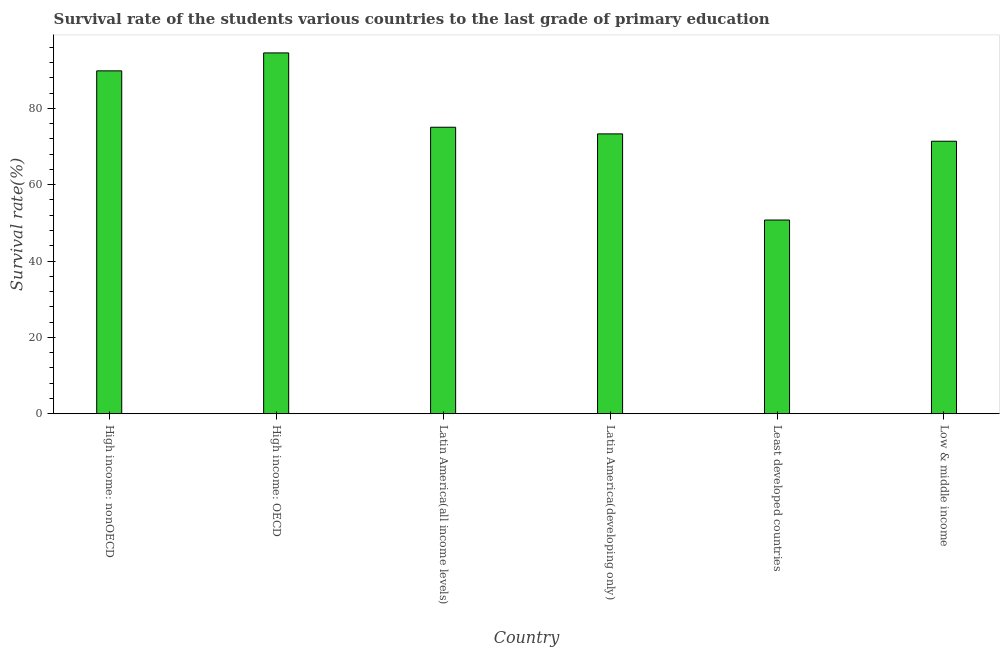Does the graph contain any zero values?
Offer a very short reply. No. What is the title of the graph?
Provide a succinct answer. Survival rate of the students various countries to the last grade of primary education. What is the label or title of the Y-axis?
Provide a short and direct response. Survival rate(%). What is the survival rate in primary education in Latin America(developing only)?
Offer a terse response. 73.32. Across all countries, what is the maximum survival rate in primary education?
Make the answer very short. 94.53. Across all countries, what is the minimum survival rate in primary education?
Your answer should be very brief. 50.75. In which country was the survival rate in primary education maximum?
Make the answer very short. High income: OECD. In which country was the survival rate in primary education minimum?
Offer a terse response. Least developed countries. What is the sum of the survival rate in primary education?
Ensure brevity in your answer.  454.88. What is the difference between the survival rate in primary education in High income: nonOECD and Latin America(all income levels)?
Your answer should be compact. 14.77. What is the average survival rate in primary education per country?
Keep it short and to the point. 75.81. What is the median survival rate in primary education?
Offer a very short reply. 74.19. What is the ratio of the survival rate in primary education in Latin America(all income levels) to that in Low & middle income?
Your answer should be compact. 1.05. What is the difference between the highest and the second highest survival rate in primary education?
Offer a terse response. 4.7. What is the difference between the highest and the lowest survival rate in primary education?
Your response must be concise. 43.78. In how many countries, is the survival rate in primary education greater than the average survival rate in primary education taken over all countries?
Your response must be concise. 2. How many countries are there in the graph?
Your answer should be compact. 6. What is the Survival rate(%) in High income: nonOECD?
Offer a very short reply. 89.83. What is the Survival rate(%) of High income: OECD?
Offer a terse response. 94.53. What is the Survival rate(%) of Latin America(all income levels)?
Your response must be concise. 75.06. What is the Survival rate(%) of Latin America(developing only)?
Give a very brief answer. 73.32. What is the Survival rate(%) in Least developed countries?
Offer a terse response. 50.75. What is the Survival rate(%) in Low & middle income?
Offer a very short reply. 71.39. What is the difference between the Survival rate(%) in High income: nonOECD and High income: OECD?
Offer a very short reply. -4.7. What is the difference between the Survival rate(%) in High income: nonOECD and Latin America(all income levels)?
Your answer should be compact. 14.77. What is the difference between the Survival rate(%) in High income: nonOECD and Latin America(developing only)?
Your answer should be compact. 16.51. What is the difference between the Survival rate(%) in High income: nonOECD and Least developed countries?
Your response must be concise. 39.08. What is the difference between the Survival rate(%) in High income: nonOECD and Low & middle income?
Offer a very short reply. 18.44. What is the difference between the Survival rate(%) in High income: OECD and Latin America(all income levels)?
Offer a very short reply. 19.47. What is the difference between the Survival rate(%) in High income: OECD and Latin America(developing only)?
Your response must be concise. 21.21. What is the difference between the Survival rate(%) in High income: OECD and Least developed countries?
Offer a terse response. 43.78. What is the difference between the Survival rate(%) in High income: OECD and Low & middle income?
Provide a succinct answer. 23.14. What is the difference between the Survival rate(%) in Latin America(all income levels) and Latin America(developing only)?
Ensure brevity in your answer.  1.74. What is the difference between the Survival rate(%) in Latin America(all income levels) and Least developed countries?
Offer a terse response. 24.31. What is the difference between the Survival rate(%) in Latin America(all income levels) and Low & middle income?
Your answer should be compact. 3.66. What is the difference between the Survival rate(%) in Latin America(developing only) and Least developed countries?
Give a very brief answer. 22.57. What is the difference between the Survival rate(%) in Latin America(developing only) and Low & middle income?
Provide a succinct answer. 1.93. What is the difference between the Survival rate(%) in Least developed countries and Low & middle income?
Ensure brevity in your answer.  -20.64. What is the ratio of the Survival rate(%) in High income: nonOECD to that in Latin America(all income levels)?
Your answer should be very brief. 1.2. What is the ratio of the Survival rate(%) in High income: nonOECD to that in Latin America(developing only)?
Make the answer very short. 1.23. What is the ratio of the Survival rate(%) in High income: nonOECD to that in Least developed countries?
Your answer should be very brief. 1.77. What is the ratio of the Survival rate(%) in High income: nonOECD to that in Low & middle income?
Provide a short and direct response. 1.26. What is the ratio of the Survival rate(%) in High income: OECD to that in Latin America(all income levels)?
Your answer should be very brief. 1.26. What is the ratio of the Survival rate(%) in High income: OECD to that in Latin America(developing only)?
Keep it short and to the point. 1.29. What is the ratio of the Survival rate(%) in High income: OECD to that in Least developed countries?
Offer a very short reply. 1.86. What is the ratio of the Survival rate(%) in High income: OECD to that in Low & middle income?
Ensure brevity in your answer.  1.32. What is the ratio of the Survival rate(%) in Latin America(all income levels) to that in Least developed countries?
Your answer should be compact. 1.48. What is the ratio of the Survival rate(%) in Latin America(all income levels) to that in Low & middle income?
Your answer should be compact. 1.05. What is the ratio of the Survival rate(%) in Latin America(developing only) to that in Least developed countries?
Offer a terse response. 1.45. What is the ratio of the Survival rate(%) in Latin America(developing only) to that in Low & middle income?
Offer a terse response. 1.03. What is the ratio of the Survival rate(%) in Least developed countries to that in Low & middle income?
Provide a succinct answer. 0.71. 